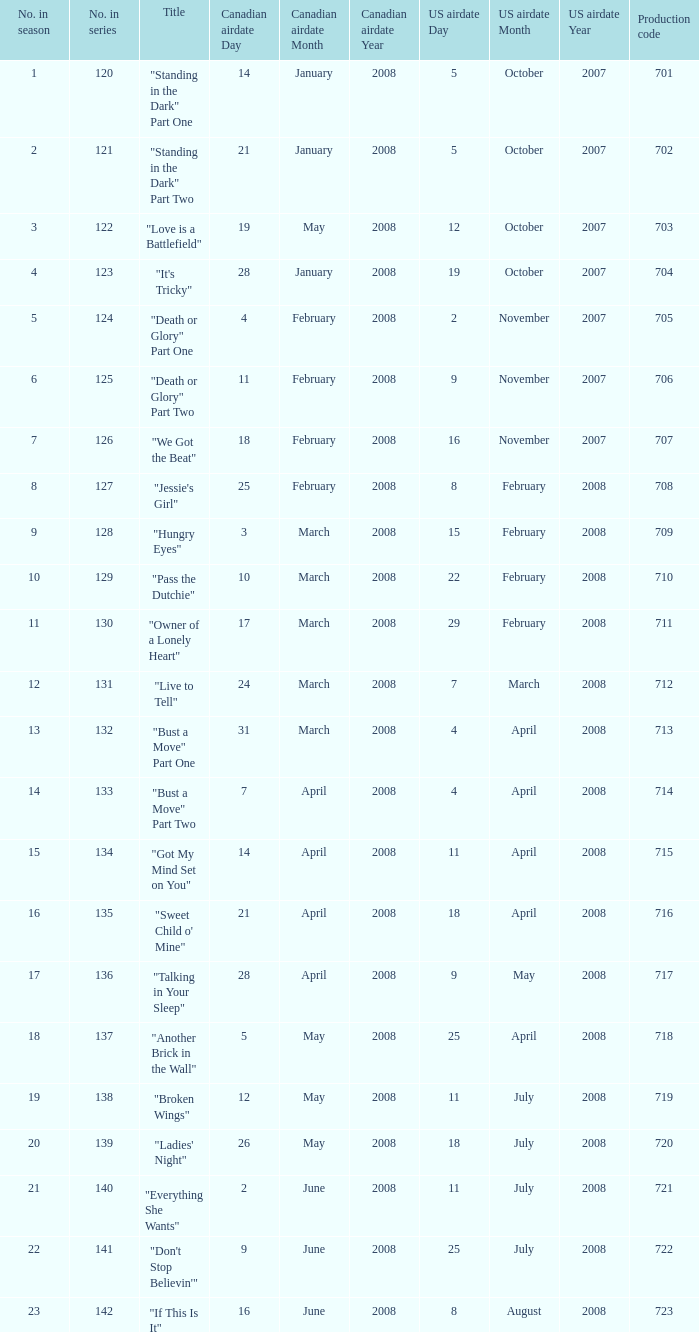For the episode(s) aired in the U.S. on 4 april 2008, what were the names? "Bust a Move" Part One, "Bust a Move" Part Two. 